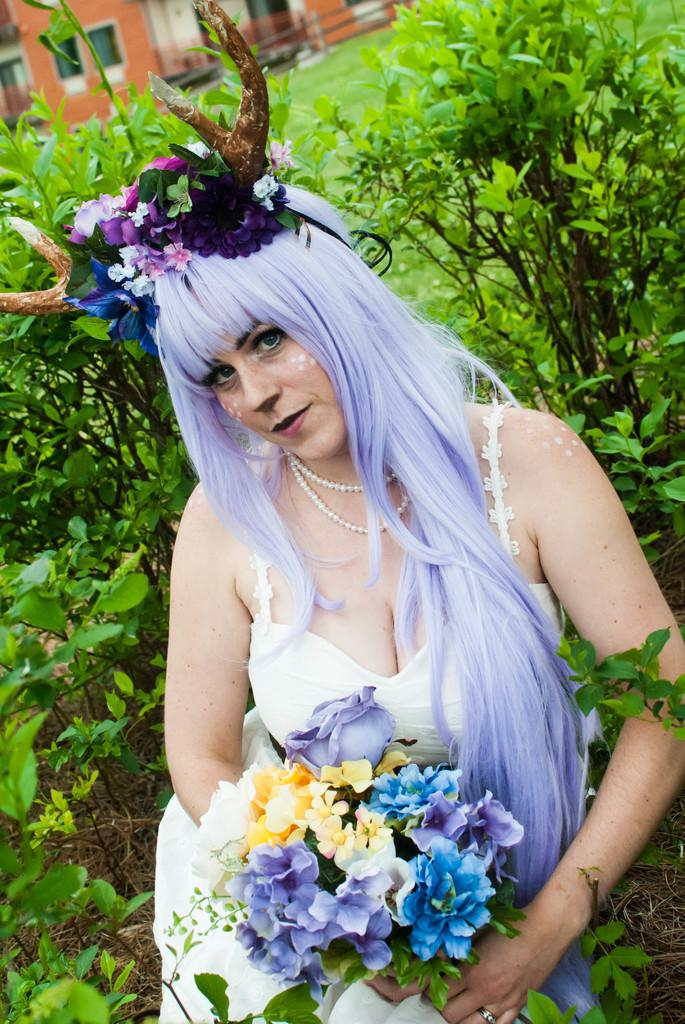Who is present in the image? There is a woman in the image. What is the woman holding in the image? The woman is holding a bunch of flowers. Can you describe the woman's appearance in the image? The woman is wearing a colorful wig on her head. What else can be seen in the image besides the woman? There are plants and a house visible in the image. What type of jeans is the woman wearing in the image? The image does not show the woman wearing jeans; she is wearing a colorful wig on her head. What news event is being discussed in the image? There is no news event being discussed in the image; it features a woman holding flowers and wearing a wig. 